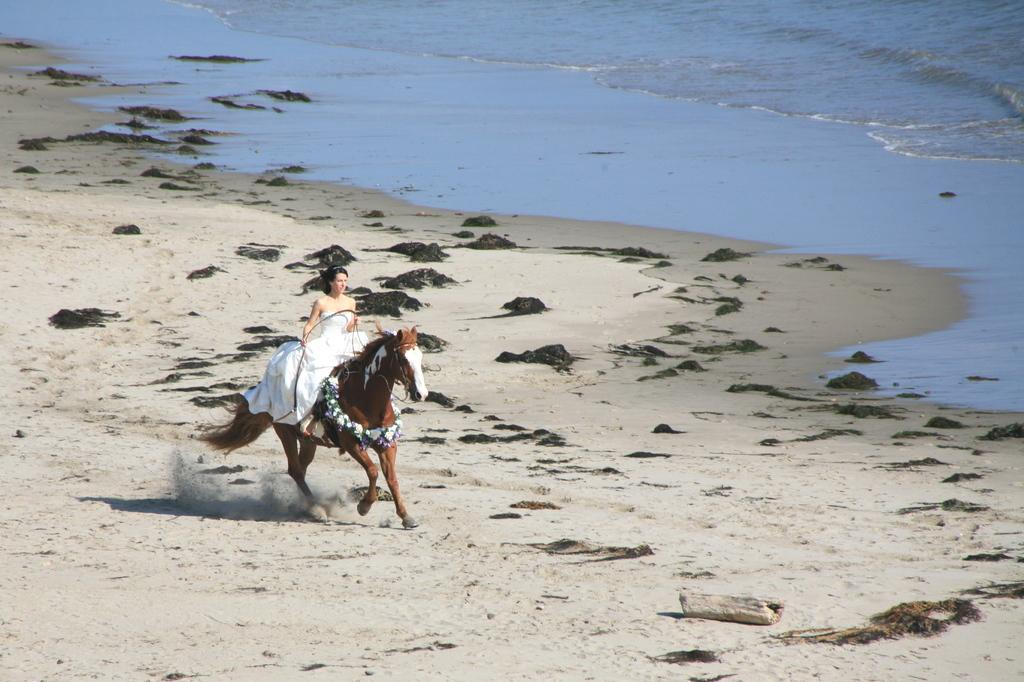Who is the main subject in the image? There is a woman in the image. What is the woman doing in the image? The woman is riding a horse. What natural feature is visible in the image? There is a sea visible in the image. Where is the sea located in relation to the woman and the horse? The sea is to the left of the woman and the horse. What type of joke is the woman telling the horse in the image? There is no indication in the image that the woman is telling a joke to the horse. 